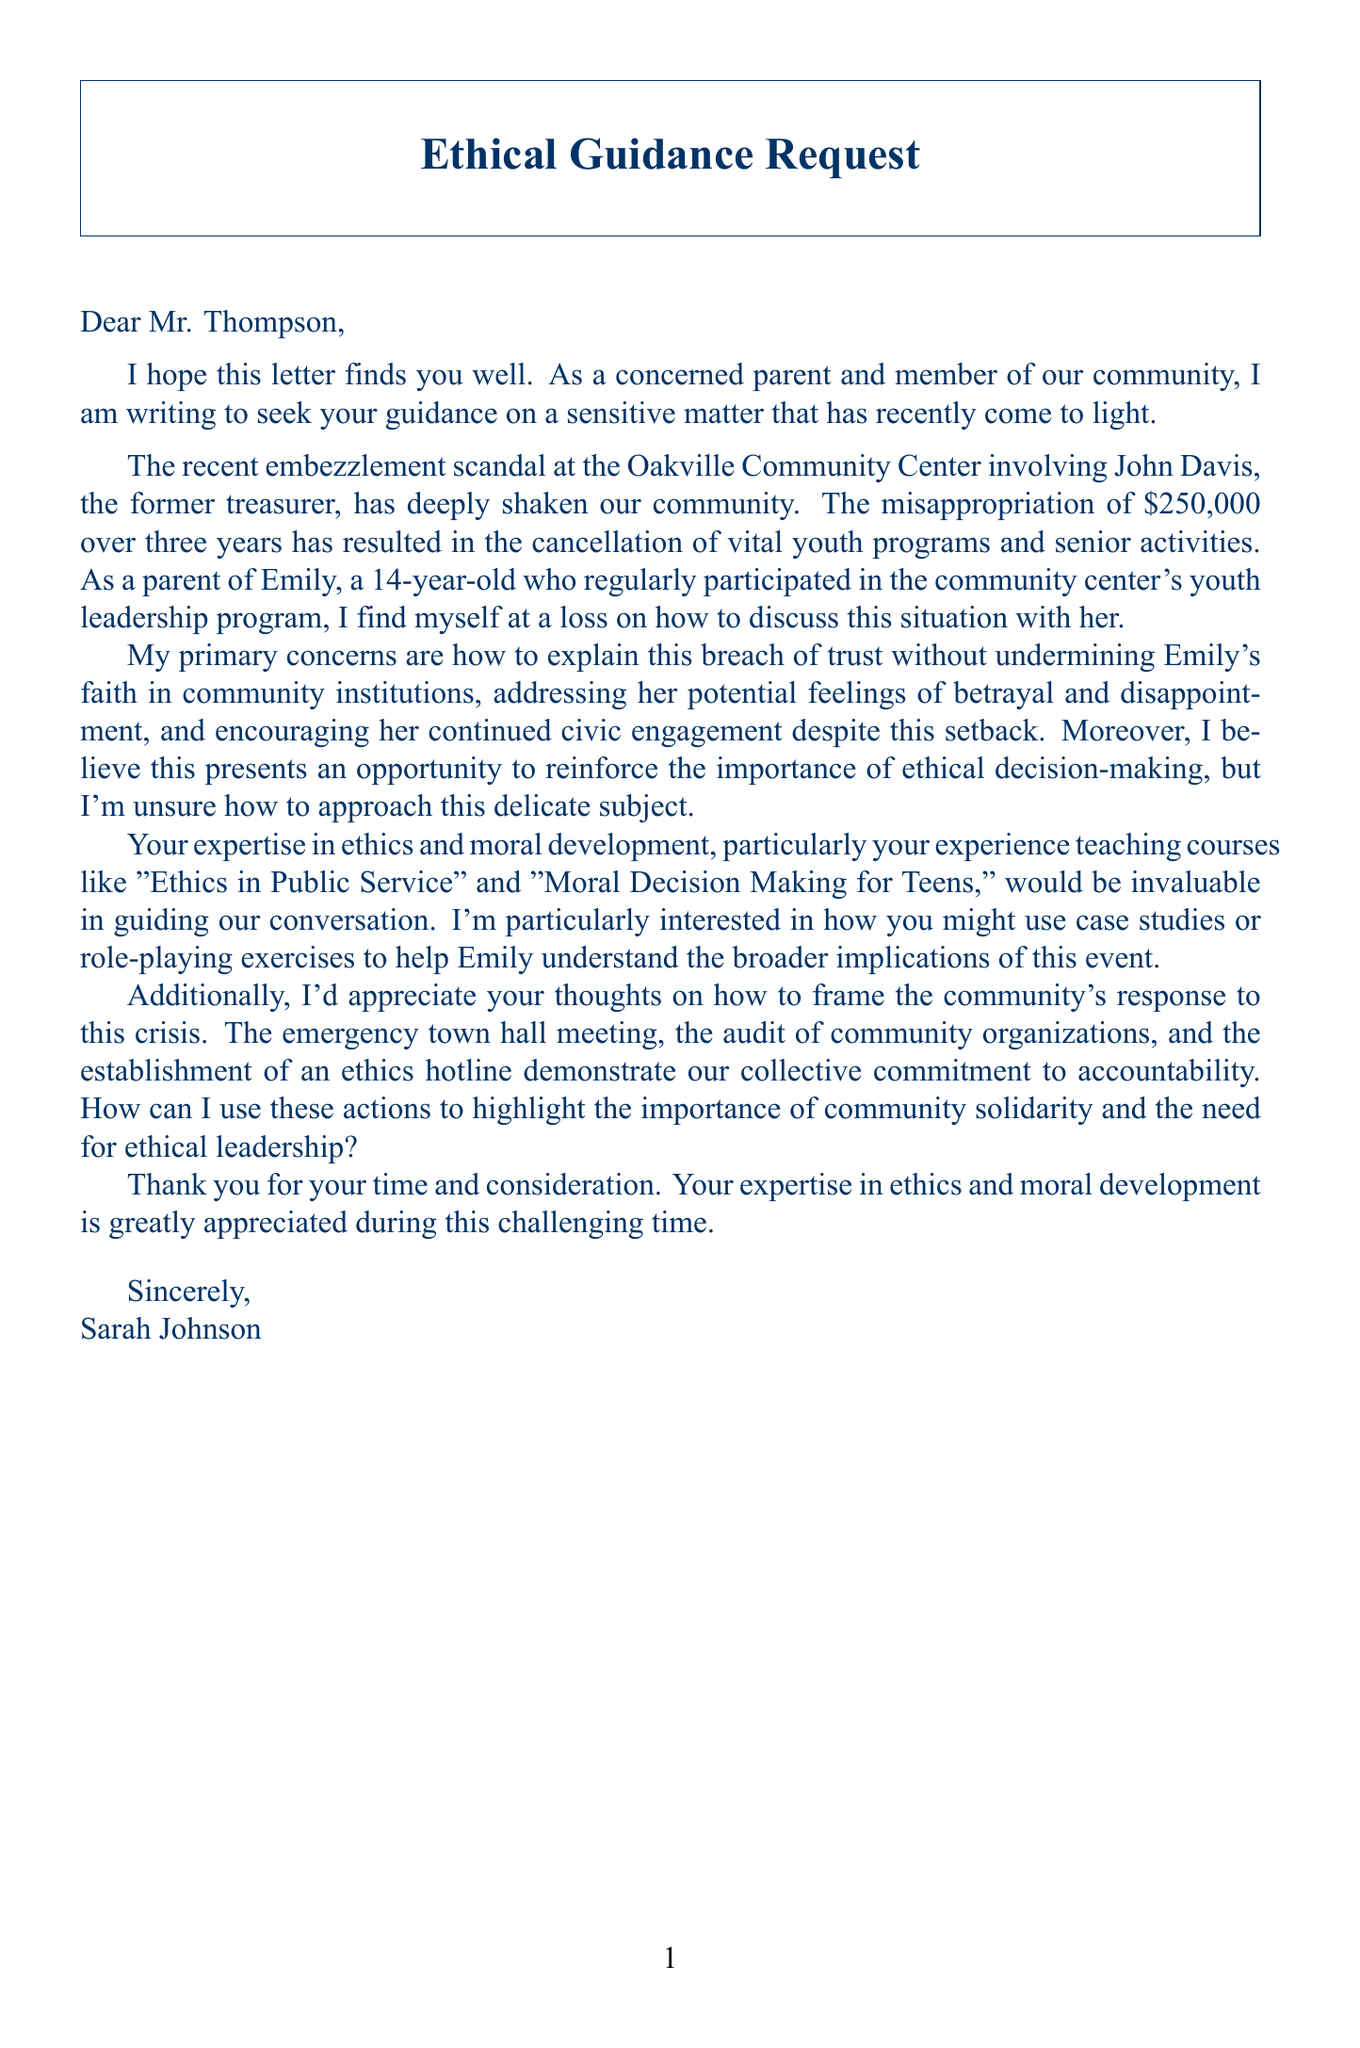What is the name of the parent who wrote the letter? The name of the parent is mentioned in the signature at the end of the letter.
Answer: Sarah Johnson What is the amount embezzled? The document states the specific amount embezzled by the perpetrator.
Answer: $250,000 Who was the former treasurer involved in the scandal? The letter identifies the individual implicated in the embezzlement.
Answer: John Davis How long did the embezzlement occur? The duration of the embezzlement is explicitly stated in the document.
Answer: 3 years What is the child's name mentioned in the letter? The document provides the name of the concerned parent's child.
Answer: Emily What is one ethical concern highlighted in the letter? The letter includes a list of ethical concerns.
Answer: Breach of trust What type of community program did Emily participate in? The document describes Emily's involvement in a specific community initiative.
Answer: Youth leadership program What is one discussion strategy suggested for explaining the situation to Emily? The document presents various strategies for discussing the issue with Emily.
Answer: Use age-appropriate language and examples What is one lesson learned from the community's response to the scandal? The letter alludes to the lessons the community derived from the situation.
Answer: Importance of oversight and checks and balances 